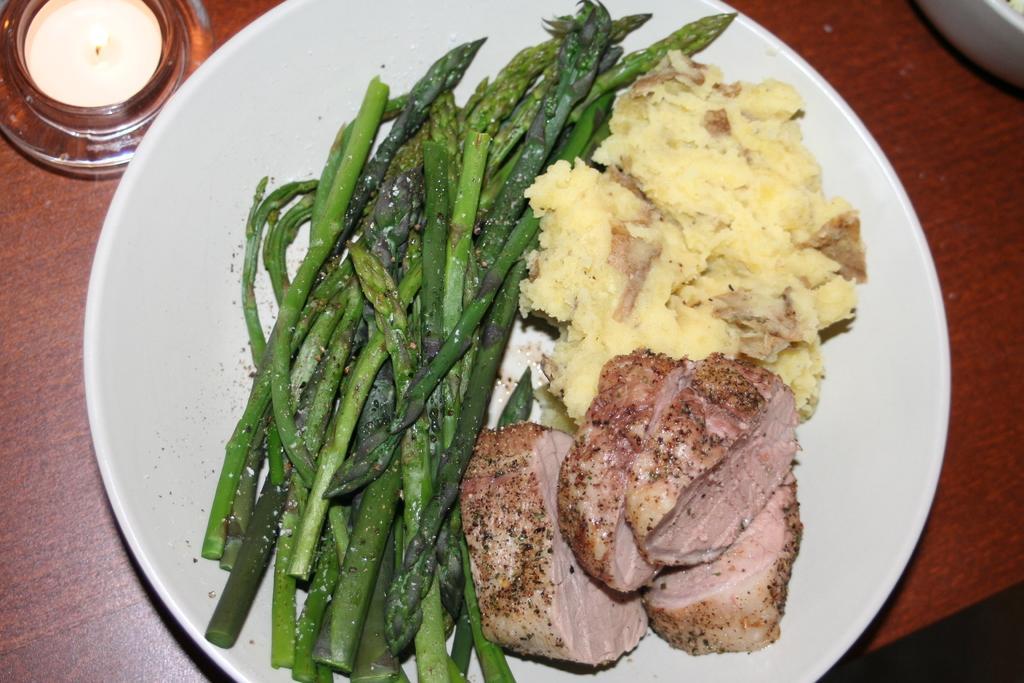Could you give a brief overview of what you see in this image? We can see plate with food,lid and bowl on the table. 